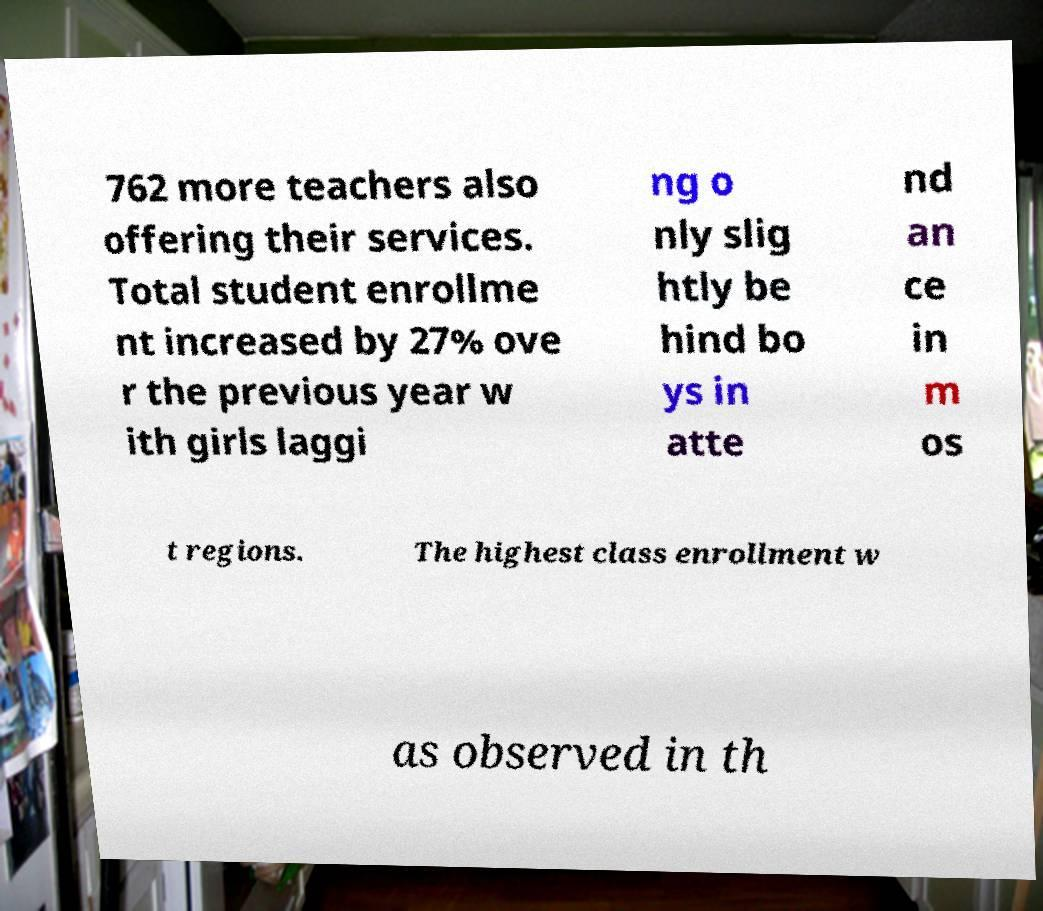Please read and relay the text visible in this image. What does it say? 762 more teachers also offering their services. Total student enrollme nt increased by 27% ove r the previous year w ith girls laggi ng o nly slig htly be hind bo ys in atte nd an ce in m os t regions. The highest class enrollment w as observed in th 